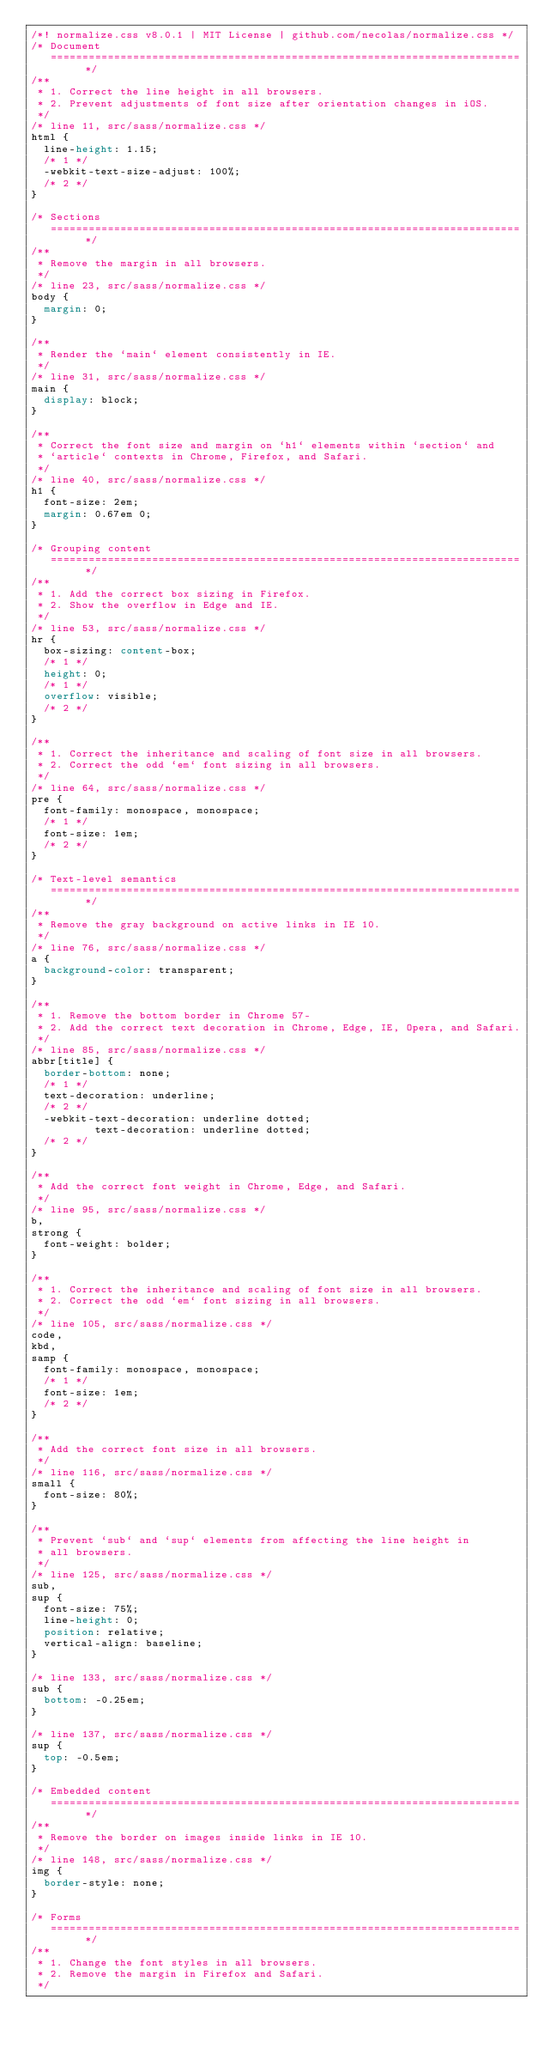<code> <loc_0><loc_0><loc_500><loc_500><_CSS_>/*! normalize.css v8.0.1 | MIT License | github.com/necolas/normalize.css */
/* Document
   ========================================================================== */
/**
 * 1. Correct the line height in all browsers.
 * 2. Prevent adjustments of font size after orientation changes in iOS.
 */
/* line 11, src/sass/normalize.css */
html {
  line-height: 1.15;
  /* 1 */
  -webkit-text-size-adjust: 100%;
  /* 2 */
}

/* Sections
   ========================================================================== */
/**
 * Remove the margin in all browsers.
 */
/* line 23, src/sass/normalize.css */
body {
  margin: 0;
}

/**
 * Render the `main` element consistently in IE.
 */
/* line 31, src/sass/normalize.css */
main {
  display: block;
}

/**
 * Correct the font size and margin on `h1` elements within `section` and
 * `article` contexts in Chrome, Firefox, and Safari.
 */
/* line 40, src/sass/normalize.css */
h1 {
  font-size: 2em;
  margin: 0.67em 0;
}

/* Grouping content
   ========================================================================== */
/**
 * 1. Add the correct box sizing in Firefox.
 * 2. Show the overflow in Edge and IE.
 */
/* line 53, src/sass/normalize.css */
hr {
  box-sizing: content-box;
  /* 1 */
  height: 0;
  /* 1 */
  overflow: visible;
  /* 2 */
}

/**
 * 1. Correct the inheritance and scaling of font size in all browsers.
 * 2. Correct the odd `em` font sizing in all browsers.
 */
/* line 64, src/sass/normalize.css */
pre {
  font-family: monospace, monospace;
  /* 1 */
  font-size: 1em;
  /* 2 */
}

/* Text-level semantics
   ========================================================================== */
/**
 * Remove the gray background on active links in IE 10.
 */
/* line 76, src/sass/normalize.css */
a {
  background-color: transparent;
}

/**
 * 1. Remove the bottom border in Chrome 57-
 * 2. Add the correct text decoration in Chrome, Edge, IE, Opera, and Safari.
 */
/* line 85, src/sass/normalize.css */
abbr[title] {
  border-bottom: none;
  /* 1 */
  text-decoration: underline;
  /* 2 */
  -webkit-text-decoration: underline dotted;
          text-decoration: underline dotted;
  /* 2 */
}

/**
 * Add the correct font weight in Chrome, Edge, and Safari.
 */
/* line 95, src/sass/normalize.css */
b,
strong {
  font-weight: bolder;
}

/**
 * 1. Correct the inheritance and scaling of font size in all browsers.
 * 2. Correct the odd `em` font sizing in all browsers.
 */
/* line 105, src/sass/normalize.css */
code,
kbd,
samp {
  font-family: monospace, monospace;
  /* 1 */
  font-size: 1em;
  /* 2 */
}

/**
 * Add the correct font size in all browsers.
 */
/* line 116, src/sass/normalize.css */
small {
  font-size: 80%;
}

/**
 * Prevent `sub` and `sup` elements from affecting the line height in
 * all browsers.
 */
/* line 125, src/sass/normalize.css */
sub,
sup {
  font-size: 75%;
  line-height: 0;
  position: relative;
  vertical-align: baseline;
}

/* line 133, src/sass/normalize.css */
sub {
  bottom: -0.25em;
}

/* line 137, src/sass/normalize.css */
sup {
  top: -0.5em;
}

/* Embedded content
   ========================================================================== */
/**
 * Remove the border on images inside links in IE 10.
 */
/* line 148, src/sass/normalize.css */
img {
  border-style: none;
}

/* Forms
   ========================================================================== */
/**
 * 1. Change the font styles in all browsers.
 * 2. Remove the margin in Firefox and Safari.
 */</code> 